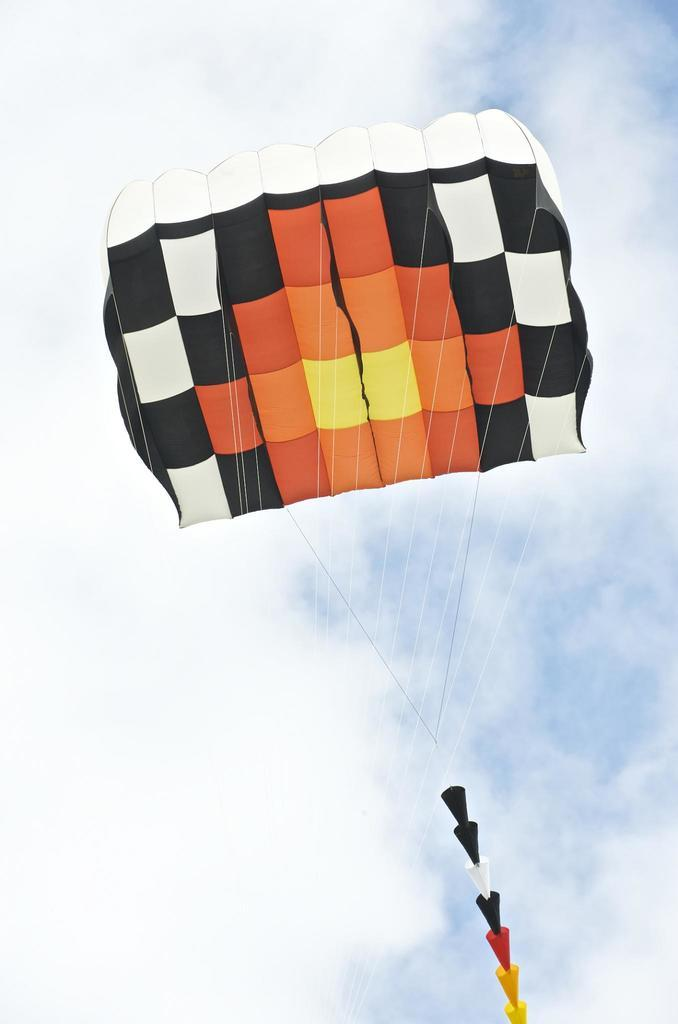What is the main object in the image? There is a kite in the image. What is the kite doing in the image? The kite is flying in the air. What can be seen in the background of the image? There is sky visible in the image. What is the condition of the sky in the image? Clouds are present in the sky. How many cats are sitting on the kite in the image? There are no cats present in the image; it features a kite flying in the air. --- Facts: 1. There is a car in the image. 2. The car is parked on the street. 3. There are trees on the side of the street. 4. The sky is visible in the image. 5. There are clouds in the sky. Absurd Topics: elephant, piano, dance Conversation: What is the main object in the image? There is a car in the image. Where is the car located in the image? The car is parked on the street. What can be seen on the side of the street in the image? There are trees on the side of the street. What is visible in the background of the image? The sky is visible in the image. What is the condition of the sky in the image? There are clouds in the sky. Reasoning: Let's think step by step in order to produce the conversation. We start by identifying the main object in the image, which is the car. Then, we describe the location of the car, which is parked on the street. Next, we mention the presence of trees on the side of the street. After that, we provide a detail about the background of the image, which is the sky. Finally, we give a detail about the sky, which is the presence of clouds. Absurd Question/Answer: How many elephants are playing the piano on the street in the image? There are no elephants playing the piano on the street in the image. --- Facts: 1. There is a group of people in the image. 2. The people are wearing costumes. 3. There is a stage in the image. 4. There are balloons in the image. Absurd Topics: dinosaur, spaceship, outer space Conversation: How many people are in the image? There is a group of people in the image. What are the people wearing in the image? The people are wearing costumes in the image. What is present in the image besides the people? There is a stage and balloons in the image. Reasoning: Let's think step by step in order to produce the conversation. We start by identifying the main subject in the image, which is the group of people. Then, we describe what the people are wearing, which are costumes. Next, we mention the presence 